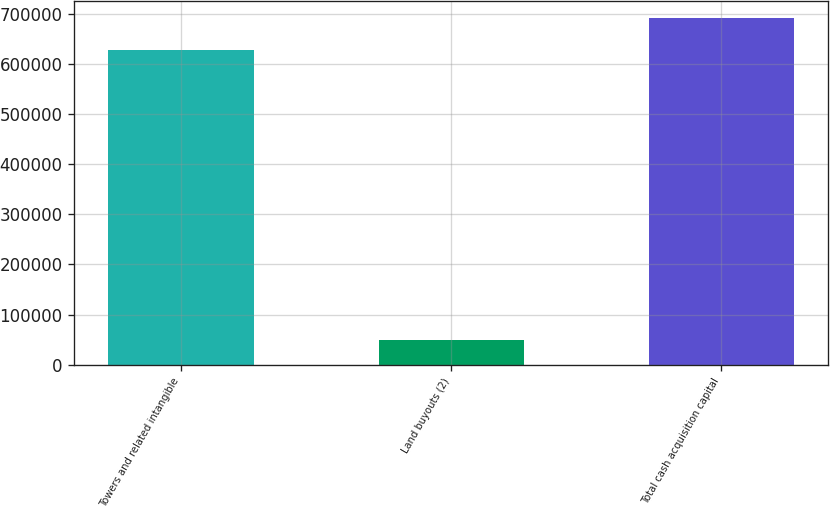Convert chart. <chart><loc_0><loc_0><loc_500><loc_500><bar_chart><fcel>Towers and related intangible<fcel>Land buyouts (2)<fcel>Total cash acquisition capital<nl><fcel>628423<fcel>48956<fcel>691265<nl></chart> 